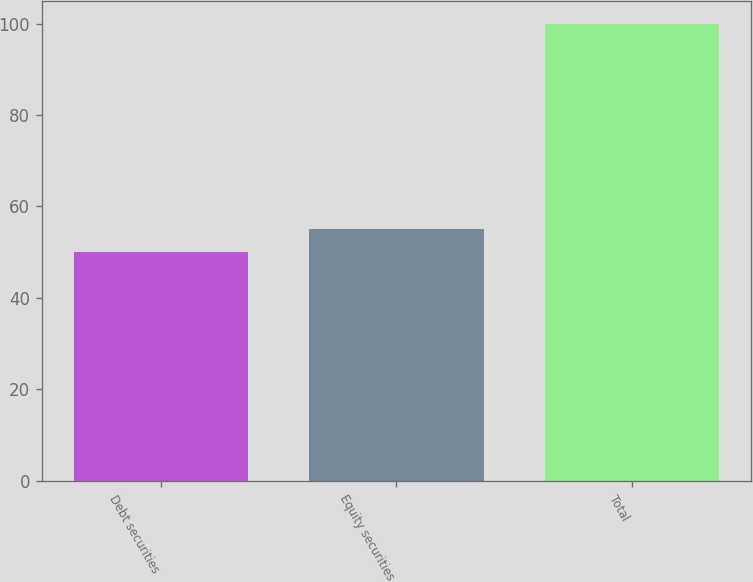Convert chart to OTSL. <chart><loc_0><loc_0><loc_500><loc_500><bar_chart><fcel>Debt securities<fcel>Equity securities<fcel>Total<nl><fcel>50<fcel>55<fcel>100<nl></chart> 